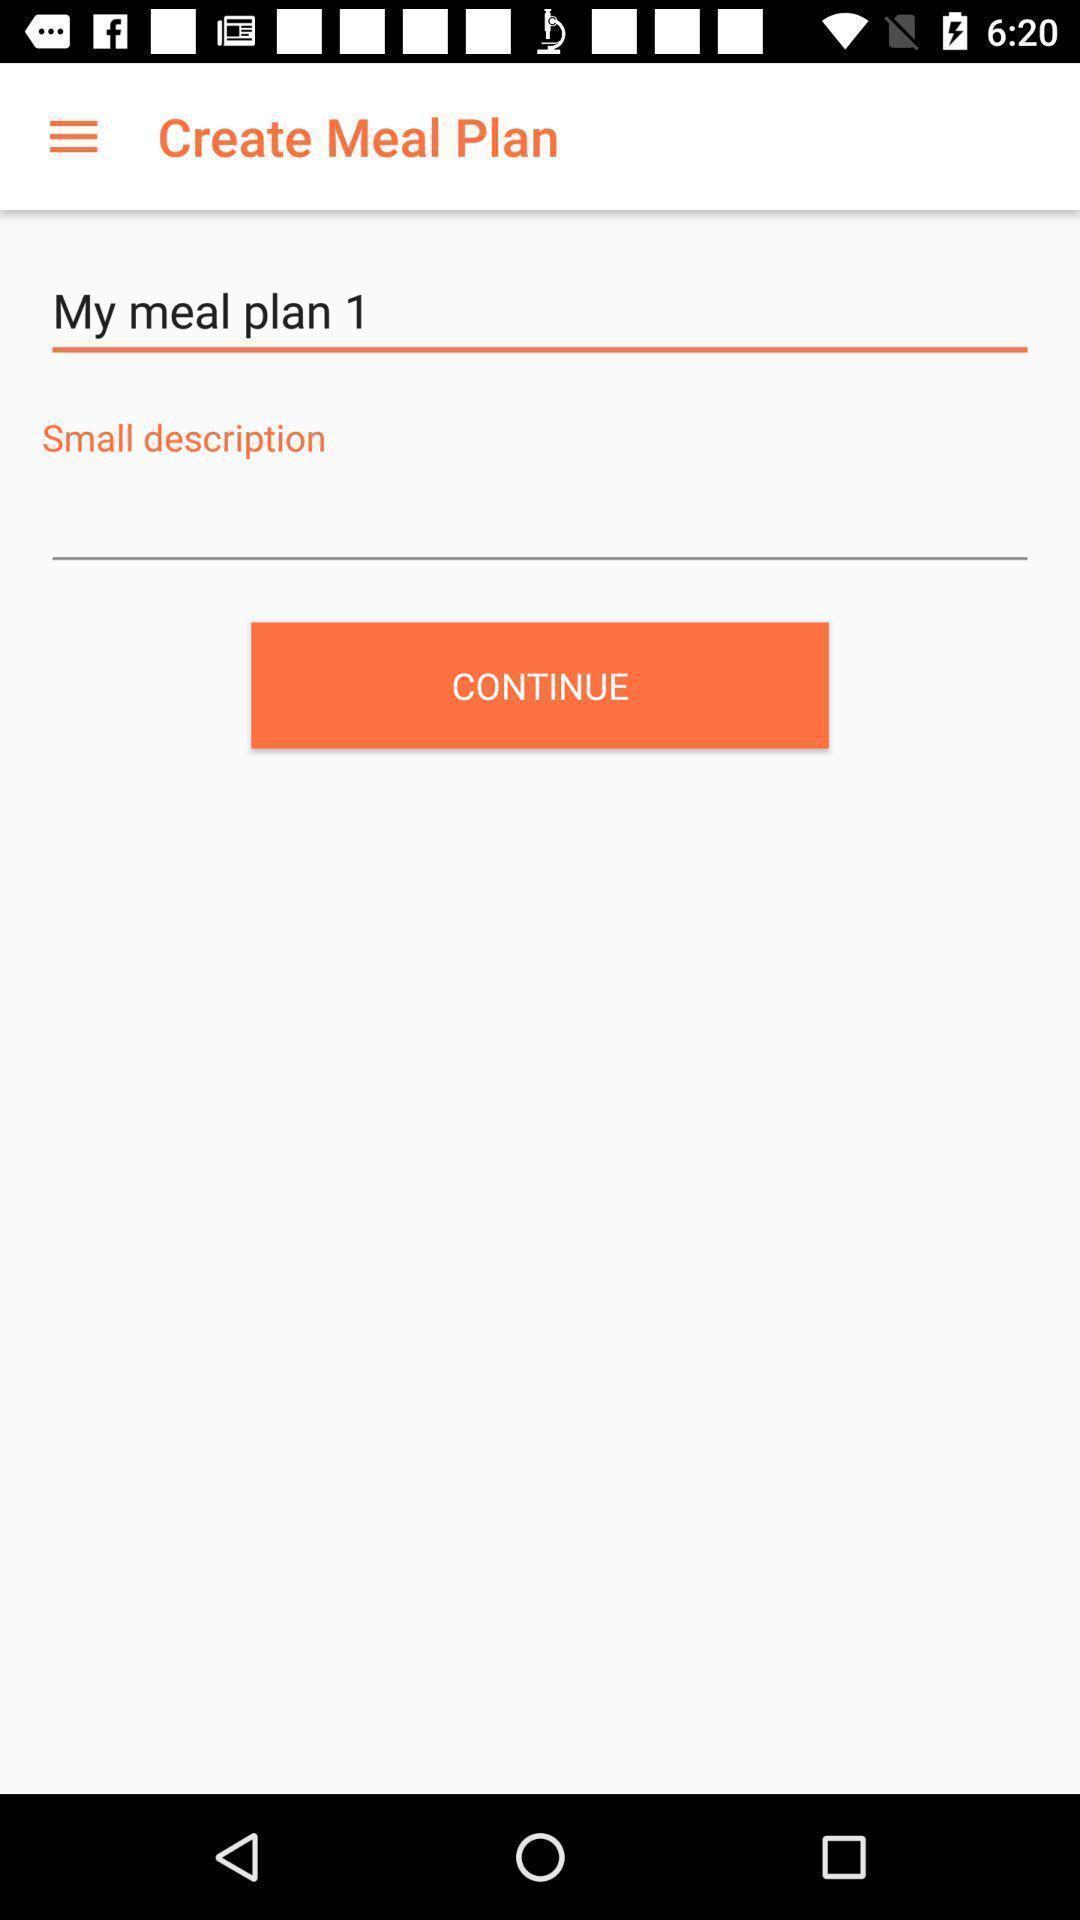What is the overall content of this screenshot? Small description in create meal plan. 